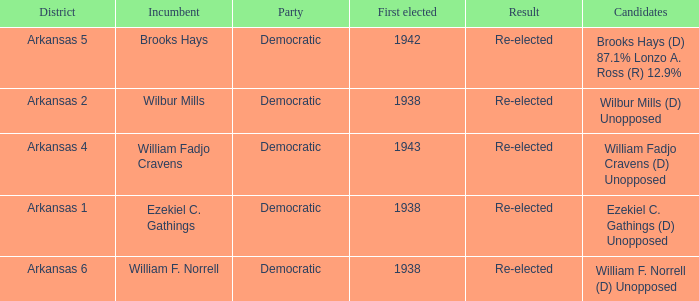What party did the incumbent from the Arkansas 5 district belong to?  Democratic. 